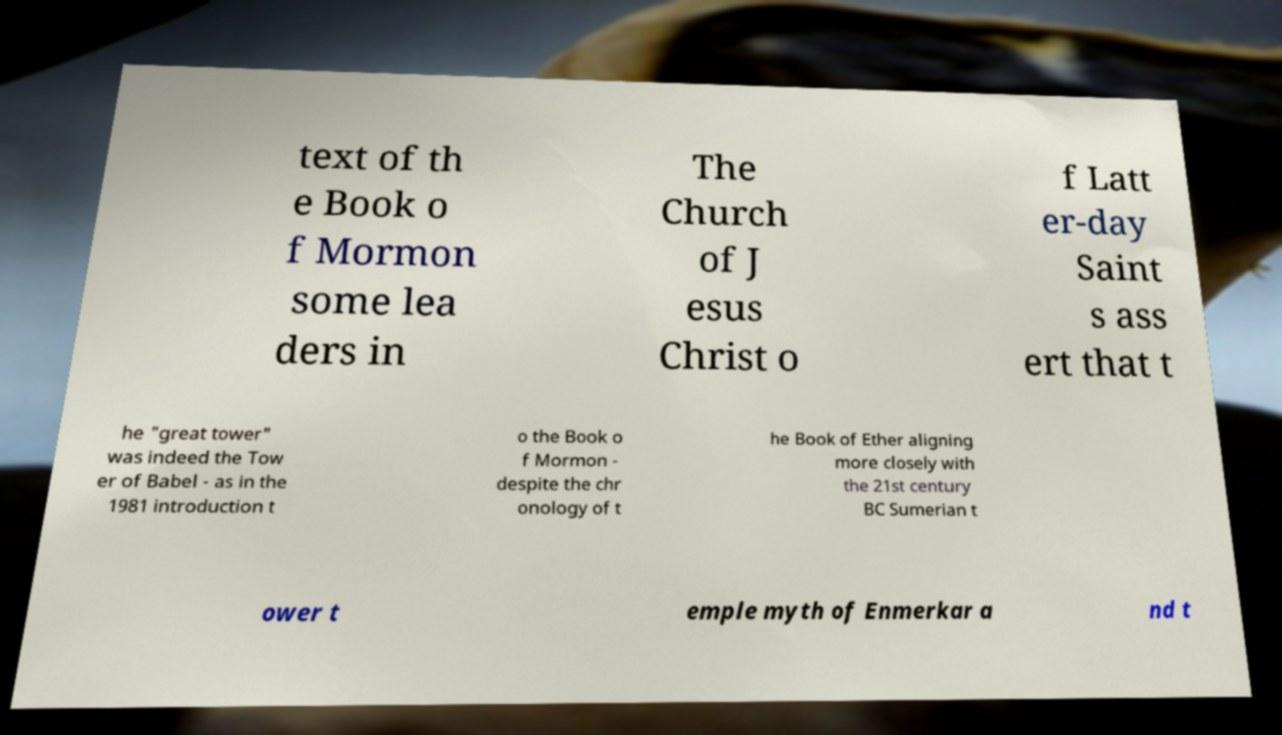For documentation purposes, I need the text within this image transcribed. Could you provide that? text of th e Book o f Mormon some lea ders in The Church of J esus Christ o f Latt er-day Saint s ass ert that t he "great tower" was indeed the Tow er of Babel - as in the 1981 introduction t o the Book o f Mormon - despite the chr onology of t he Book of Ether aligning more closely with the 21st century BC Sumerian t ower t emple myth of Enmerkar a nd t 